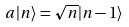Convert formula to latex. <formula><loc_0><loc_0><loc_500><loc_500>a | n \rangle = \sqrt { n } | n - 1 \rangle</formula> 